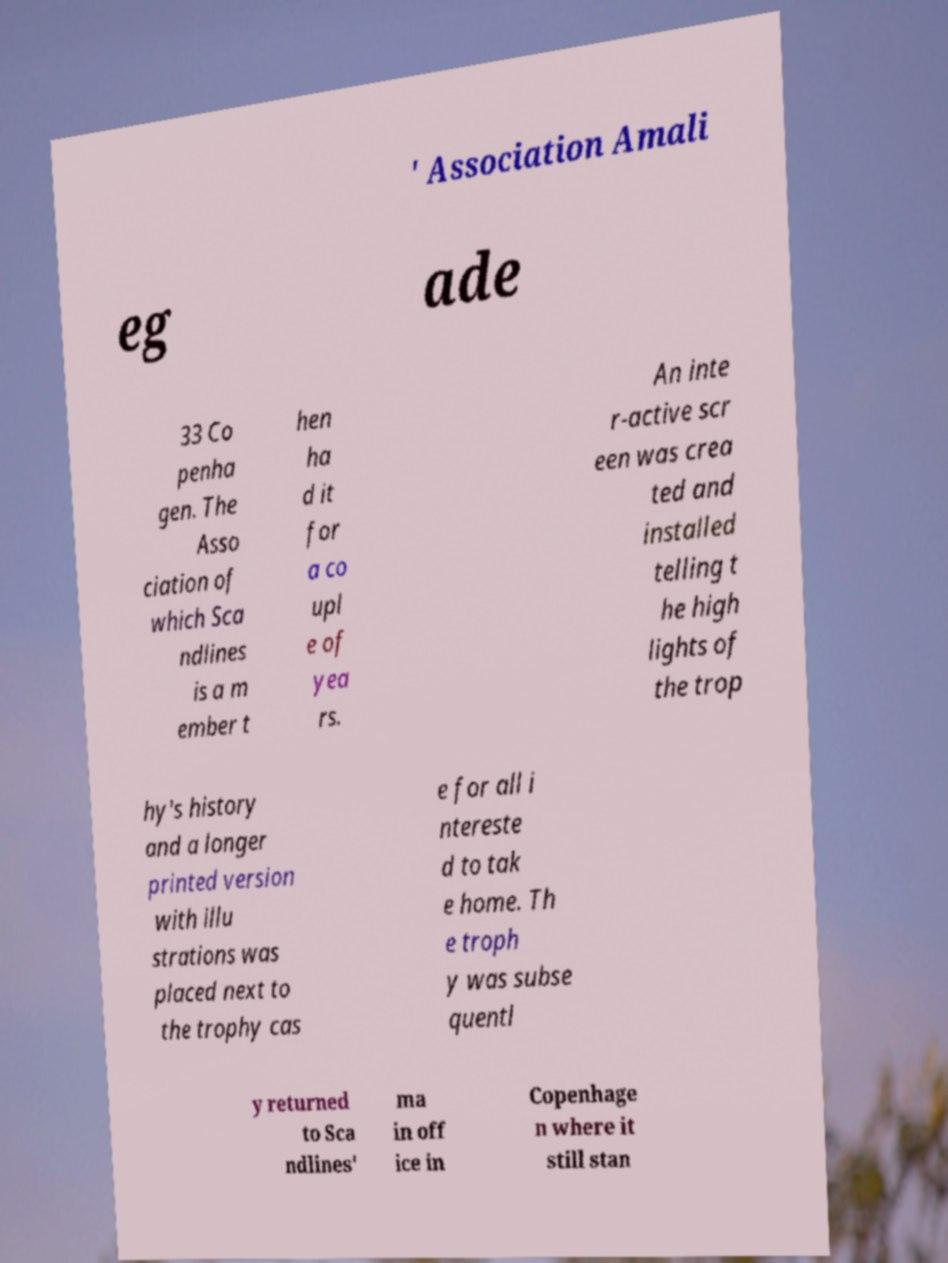Please read and relay the text visible in this image. What does it say? ' Association Amali eg ade 33 Co penha gen. The Asso ciation of which Sca ndlines is a m ember t hen ha d it for a co upl e of yea rs. An inte r-active scr een was crea ted and installed telling t he high lights of the trop hy's history and a longer printed version with illu strations was placed next to the trophy cas e for all i ntereste d to tak e home. Th e troph y was subse quentl y returned to Sca ndlines' ma in off ice in Copenhage n where it still stan 